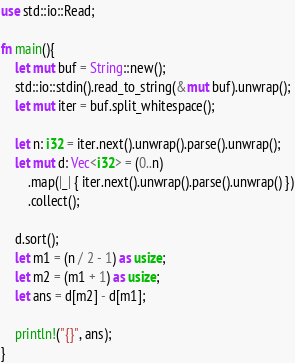Convert code to text. <code><loc_0><loc_0><loc_500><loc_500><_Rust_>use std::io::Read;

fn main(){
    let mut buf = String::new();
    std::io::stdin().read_to_string(&mut buf).unwrap();
    let mut iter = buf.split_whitespace();

    let n: i32 = iter.next().unwrap().parse().unwrap();
    let mut d: Vec<i32> = (0..n)
        .map(|_| { iter.next().unwrap().parse().unwrap() })
        .collect();

    d.sort();
    let m1 = (n / 2 - 1) as usize;
    let m2 = (m1 + 1) as usize;
    let ans = d[m2] - d[m1];

    println!("{}", ans);
}</code> 